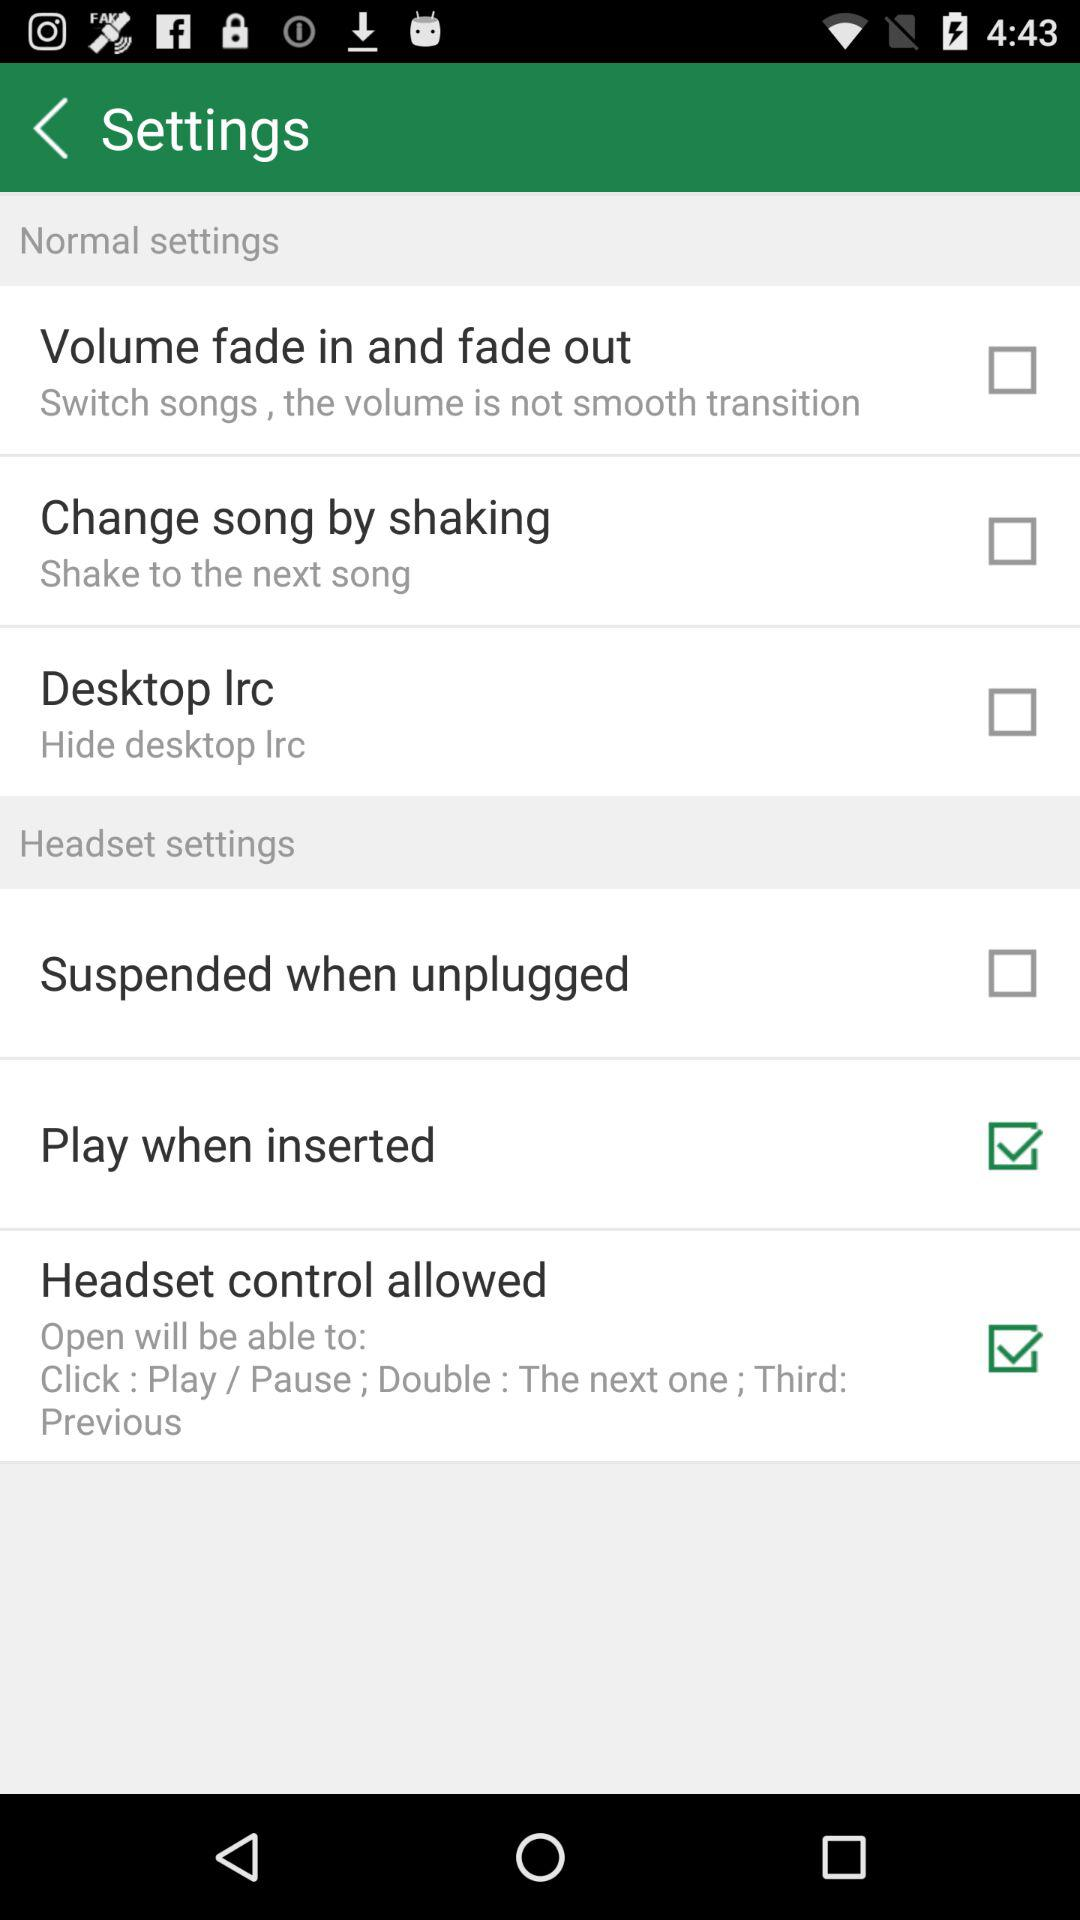What is the name of the application?
When the provided information is insufficient, respond with <no answer>. <no answer> 